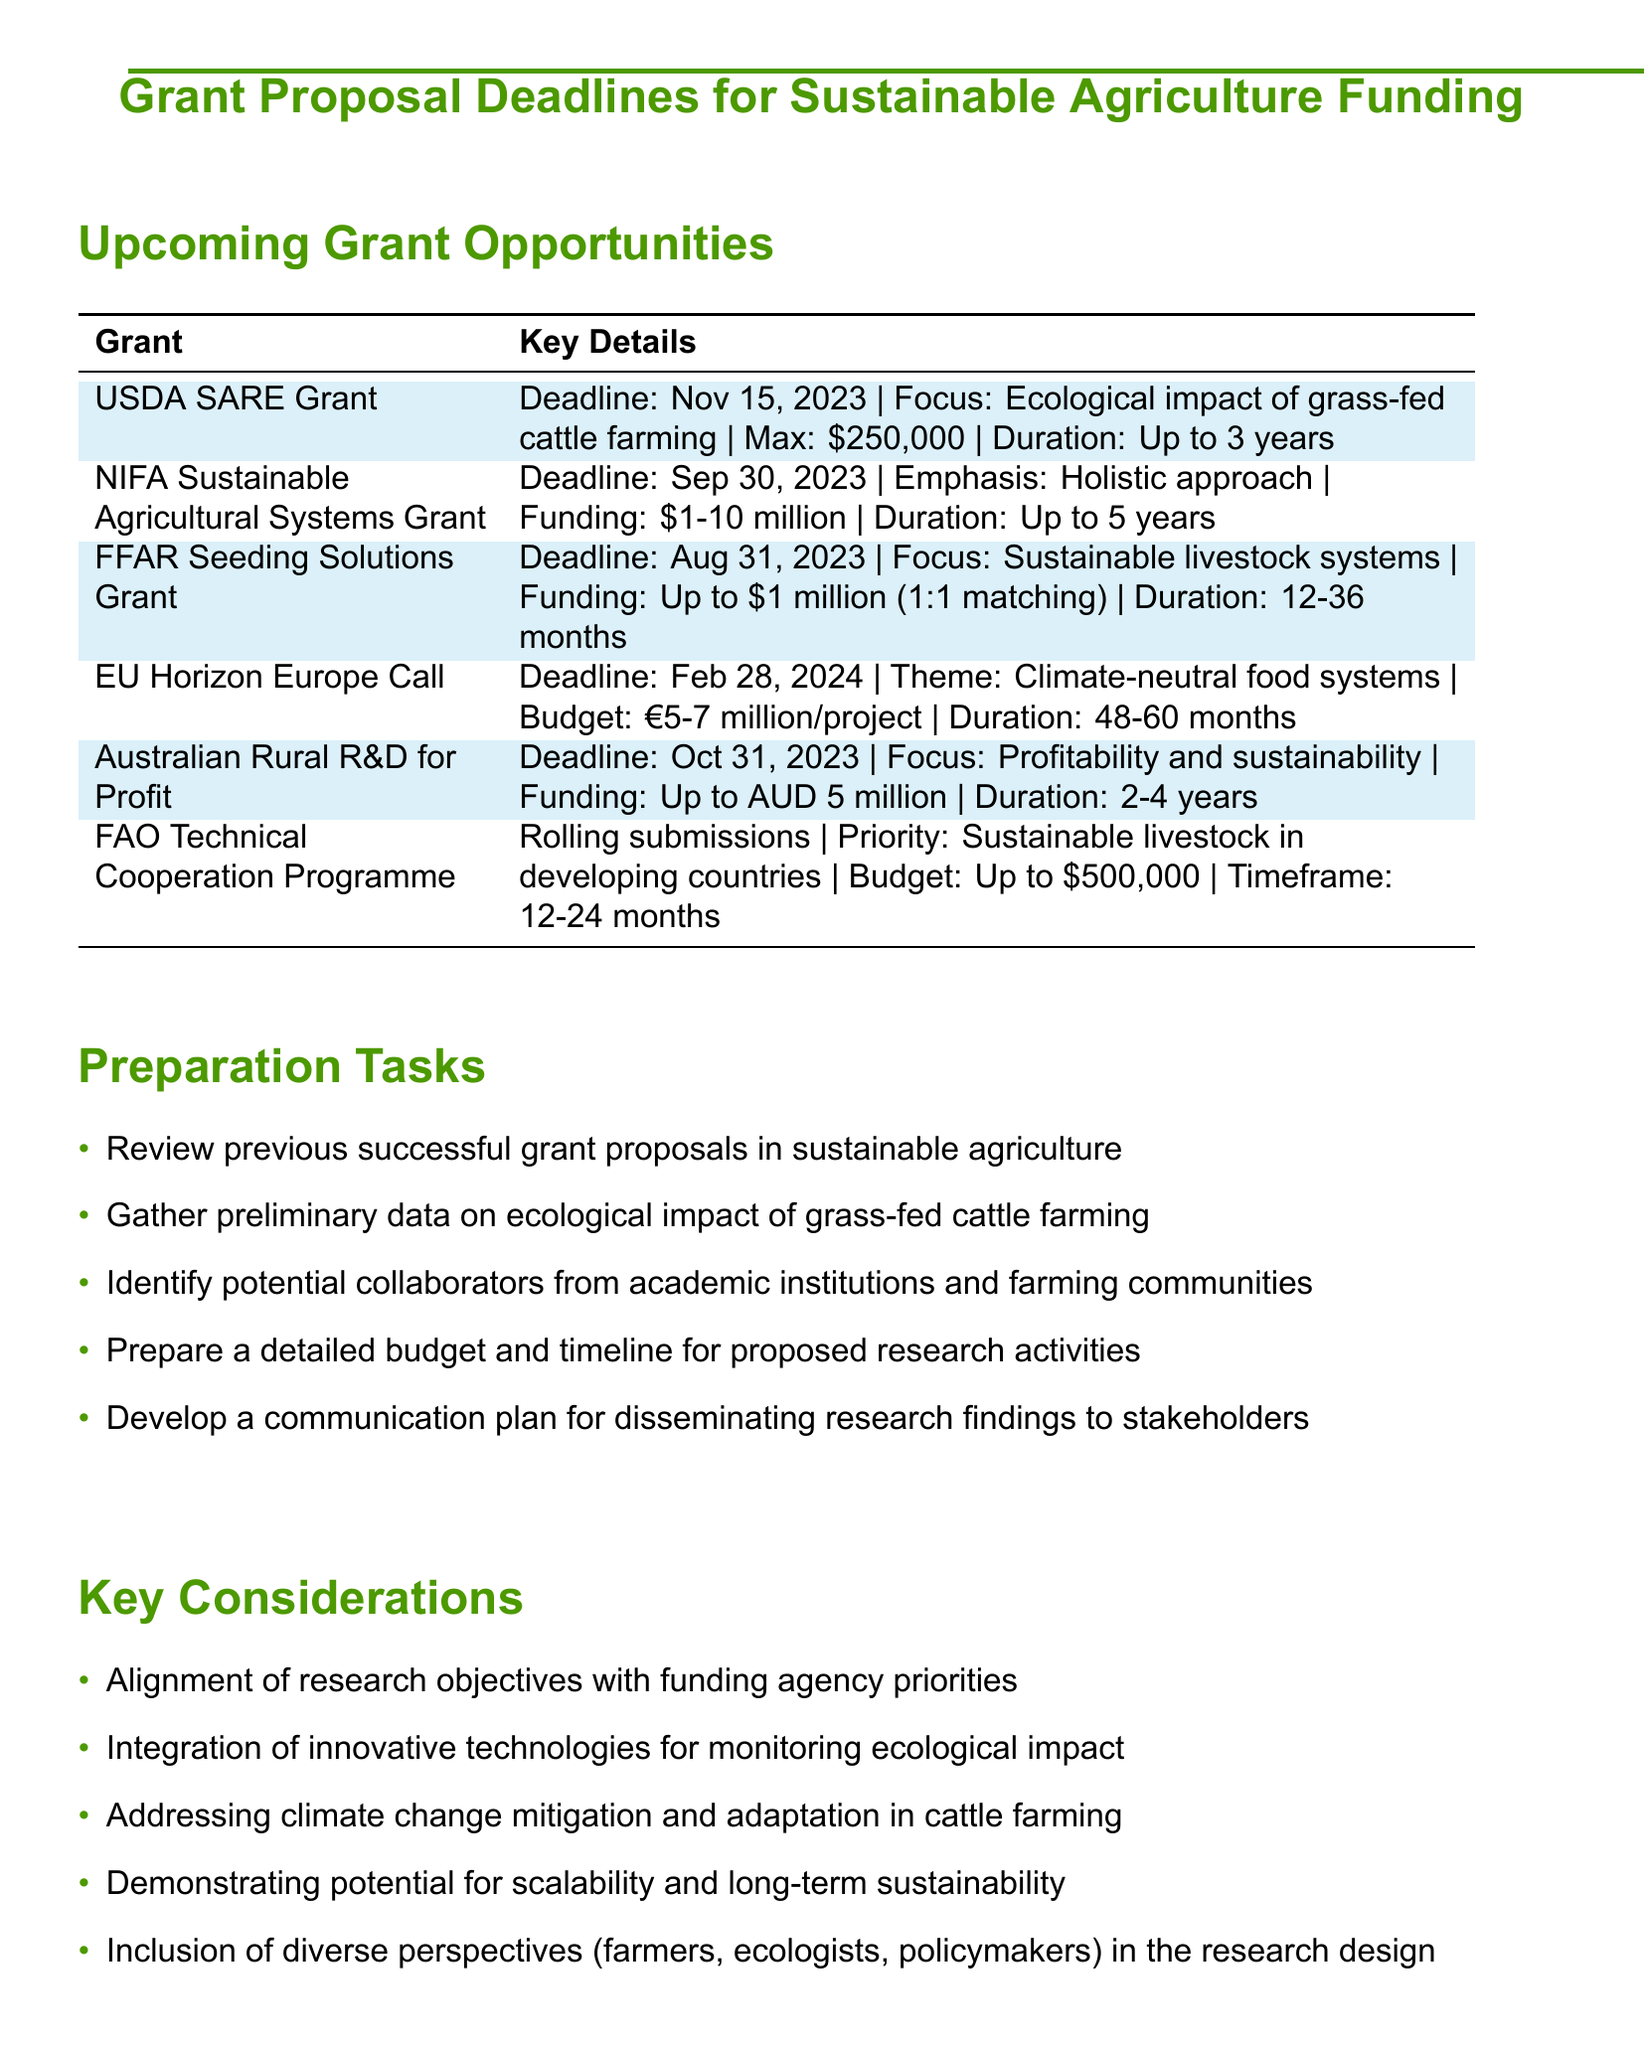What is the funding amount for the USDA SARE Grant? The funding amount for the USDA SARE Grant is provided in the detail section, indicating a maximum of $250,000.
Answer: $250,000 What is the deadline for the NIFA Sustainable Agricultural Systems Grant? The deadline is found in the details of the grant, which states that it is September 30, 2023.
Answer: September 30, 2023 What is the duration of the FFAR Seeding Solutions Grant? The duration for the FFAR Seeding Solutions Grant is mentioned as 12-36 months in the document.
Answer: 12-36 months Which grant requires collaboration with farmers and ranchers? The USDA SARE Grant has a specific requirement for collaboration with farmers and ranchers as highlighted in the details.
Answer: USDA SARE Grant What is the focus area of the FAO Technical Cooperation Programme? The FAO Technical Cooperation Programme focuses on sustainable livestock management in developing countries, as indicated in the details.
Answer: Sustainable livestock management in developing countries How many countries are required for the EU Horizon Europe Sustainable Food Systems Call? The document specifies that a minimum of 3 EU countries is required for the EU Horizon Europe Sustainable Food Systems Call.
Answer: 3 EU countries What is one of the key considerations for the grant proposal? Alignment of research objectives with funding agency priorities is noted as one of the key considerations in the document.
Answer: Alignment of research objectives with funding agency priorities What is the deadline for the Australian Government's Rural R&D for Profit Programme? The deadline is explicitly stated as October 31, 2023 in the details for this programme.
Answer: October 31, 2023 What type of research teams does the NIFA grant emphasize? The document indicates that interdisciplinary research teams are a key component of the NIFA Sustainable Agricultural Systems Grant.
Answer: Interdisciplinary research teams 